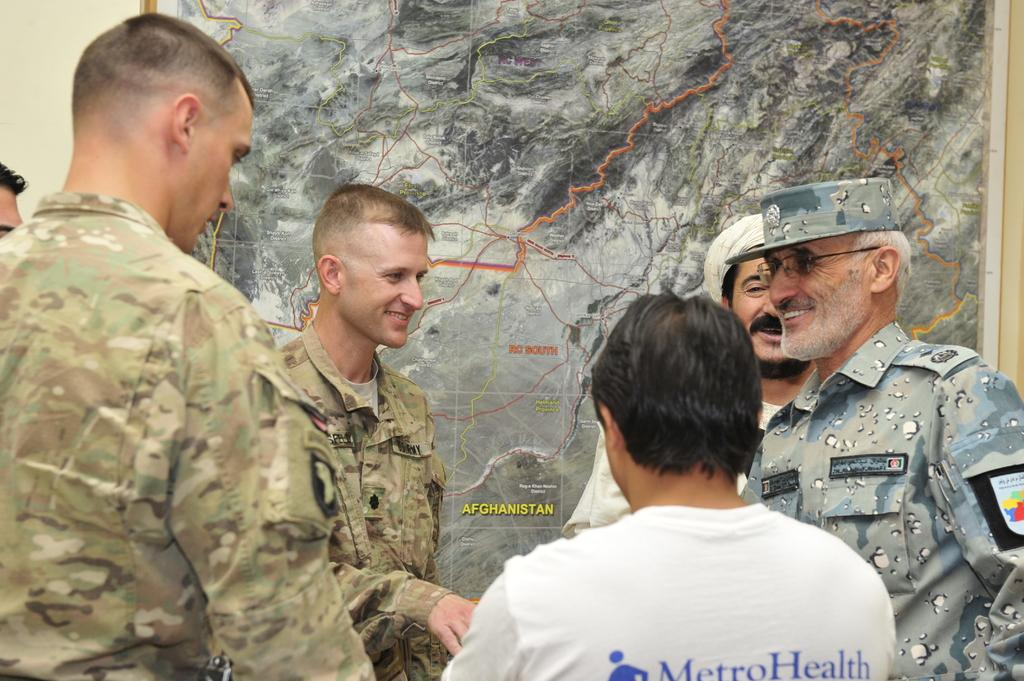How many people are in the image? There are people standing in the image. Can you describe one of the individuals in the image? One person on the right is wearing glasses (specs) and a cap. What can be seen in the background of the image? There is a wall in the background of the image. What is on the wall in the image? There is a map on the wall. What type of root is being treated in the image? There is no root present in the image. What decision can be seen being made by the people in the image? There is no indication of a decision being made by the people in the image. 